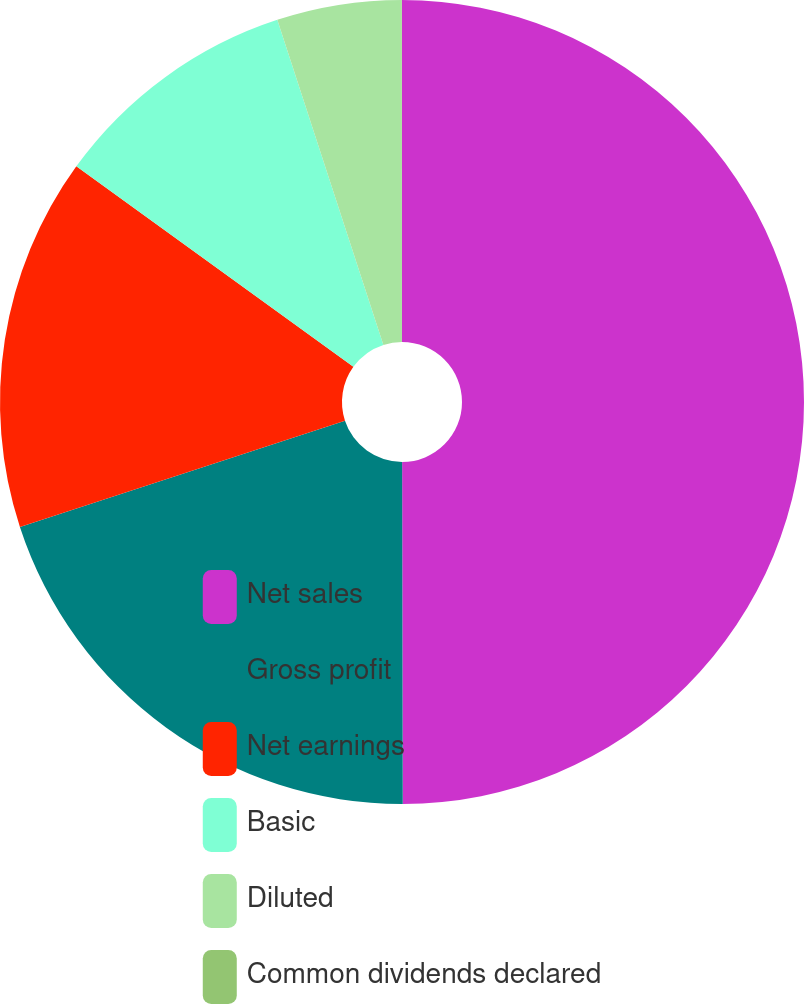Convert chart. <chart><loc_0><loc_0><loc_500><loc_500><pie_chart><fcel>Net sales<fcel>Gross profit<fcel>Net earnings<fcel>Basic<fcel>Diluted<fcel>Common dividends declared<nl><fcel>49.97%<fcel>20.0%<fcel>15.0%<fcel>10.01%<fcel>5.01%<fcel>0.01%<nl></chart> 